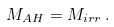<formula> <loc_0><loc_0><loc_500><loc_500>M _ { A H } = M _ { i r r } \, .</formula> 